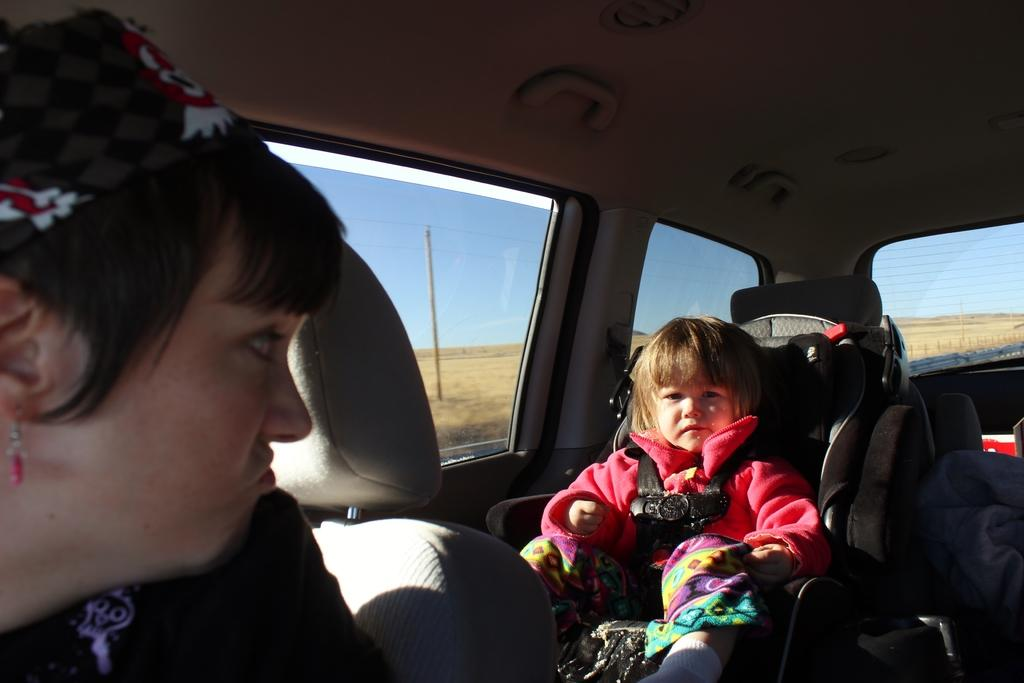Who are the people in the image? There is a girl and a woman in the image. Where are the girl and woman located in the image? Both the girl and woman are sitting inside a car. What can be seen through the car window? The sky, a pole, and a dried grass land area are visible through the car window. What type of behavior is the girl exhibiting in the image? The image does not provide information about the girl's behavior, as it only shows her sitting inside the car. What thoughts might the woman be having while sitting in the car? The image does not provide information about the woman's thoughts, as it only shows her sitting inside the car. 